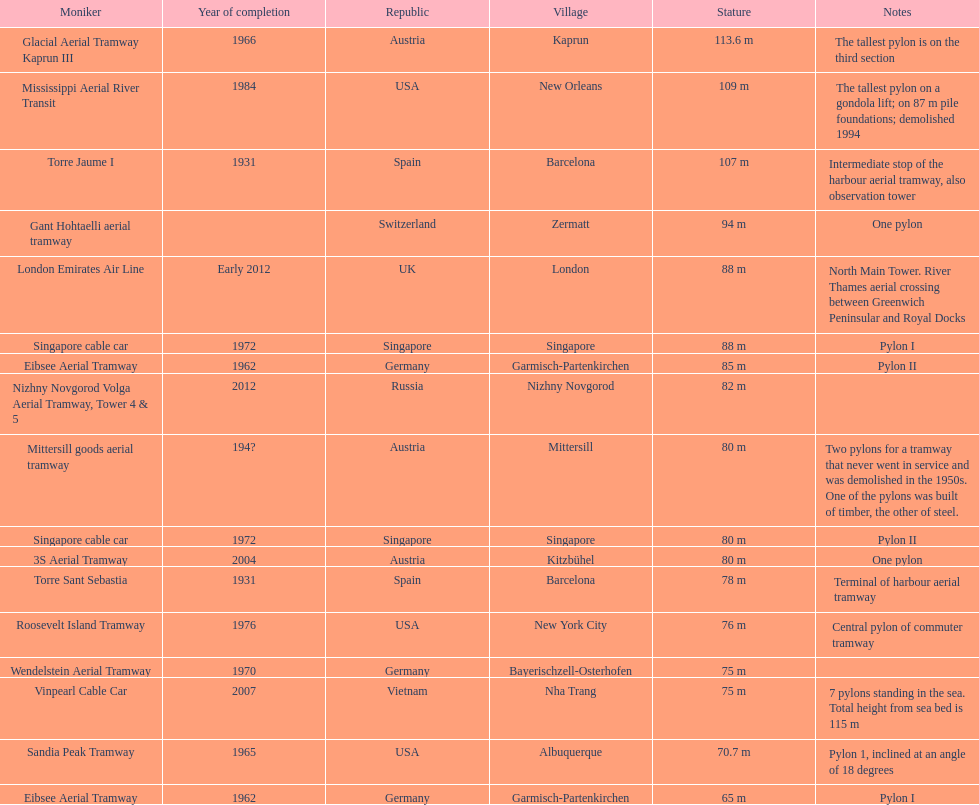The london emirates air line pylon has the same height as which pylon? Singapore cable car. 